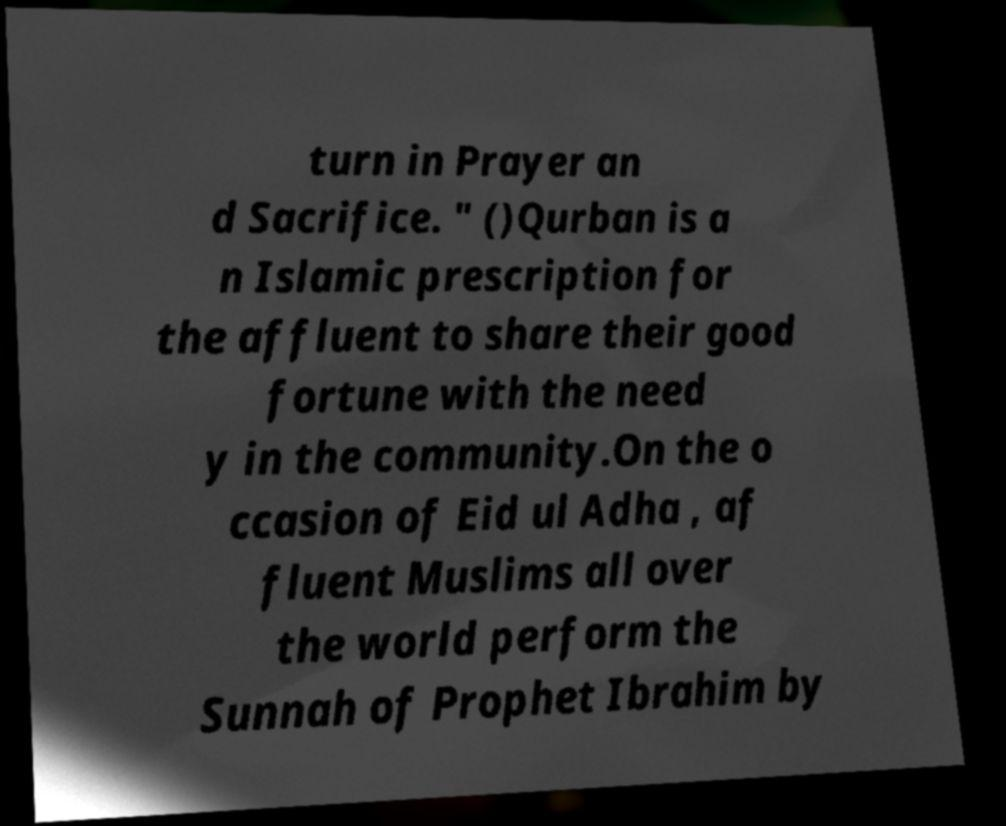Could you assist in decoding the text presented in this image and type it out clearly? turn in Prayer an d Sacrifice. " ()Qurban is a n Islamic prescription for the affluent to share their good fortune with the need y in the community.On the o ccasion of Eid ul Adha , af fluent Muslims all over the world perform the Sunnah of Prophet Ibrahim by 